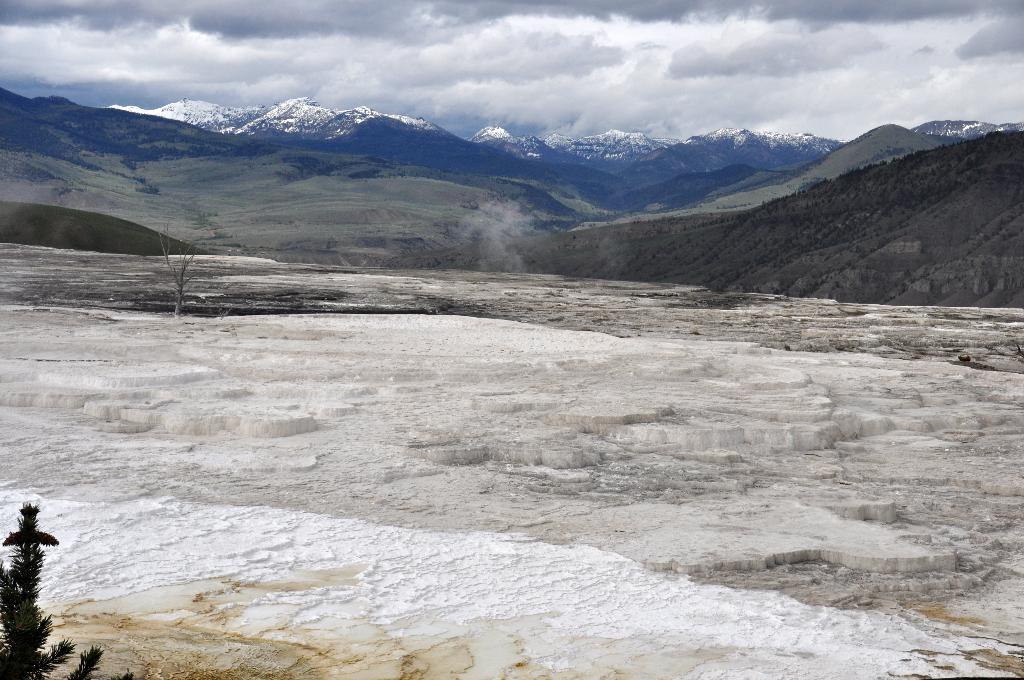Describe this image in one or two sentences. In this picture we can see trees,mountains and we can see sky in the background. 